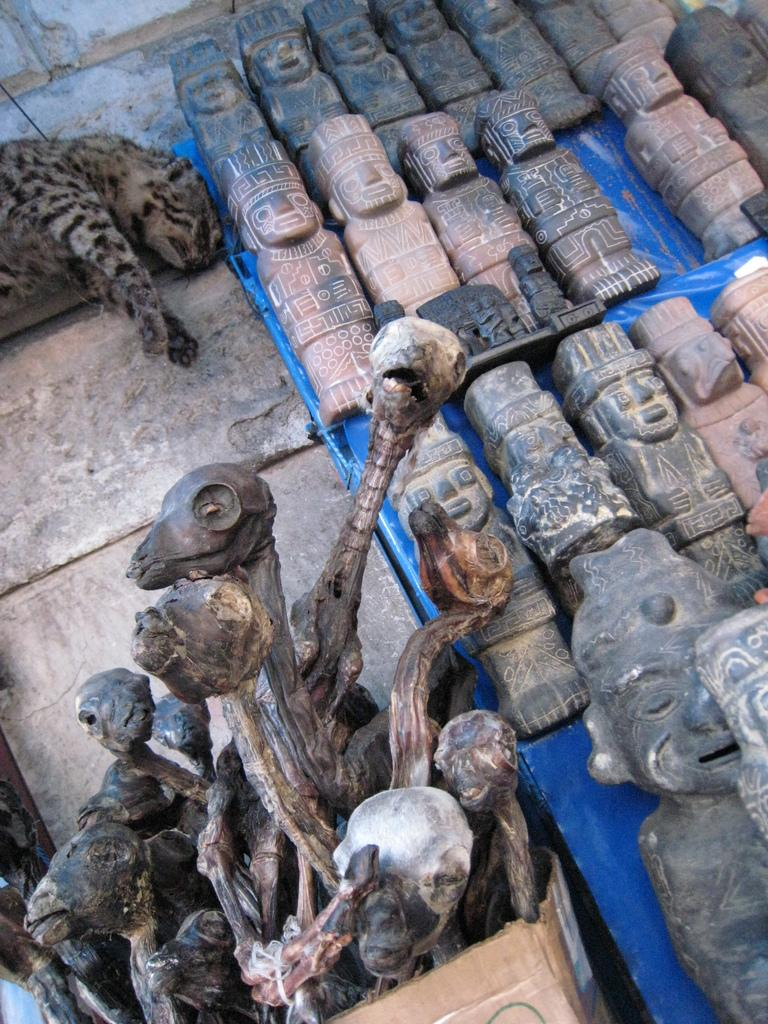What type of objects are featured in the image? There are wooden carvings in the image. Can you describe the animal in the image? There is an animal in the image, but the specific type of animal is not mentioned in the provided facts. What color is the bursting company balloon in the image? There is no bursting company balloon present in the image. 